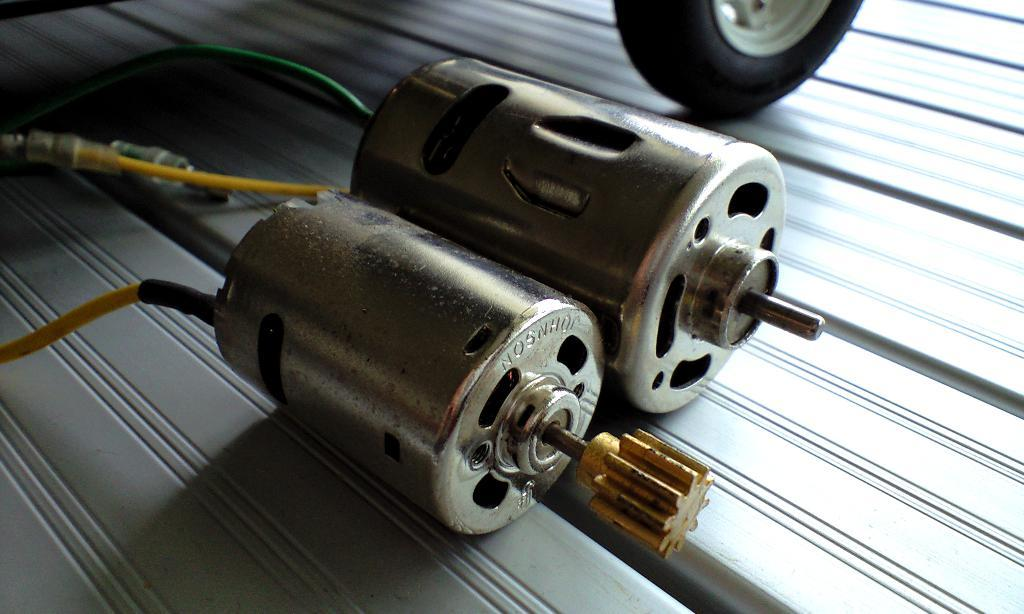What type of objects are present in the picture? There are mini electric motors and wires in the picture. Can you describe the location of the Tyre in the picture? The Tyre is on the top right side of the picture. What title does the dad give to this picture? There is no information about a dad or a title in the provided facts, so we cannot answer this question. 